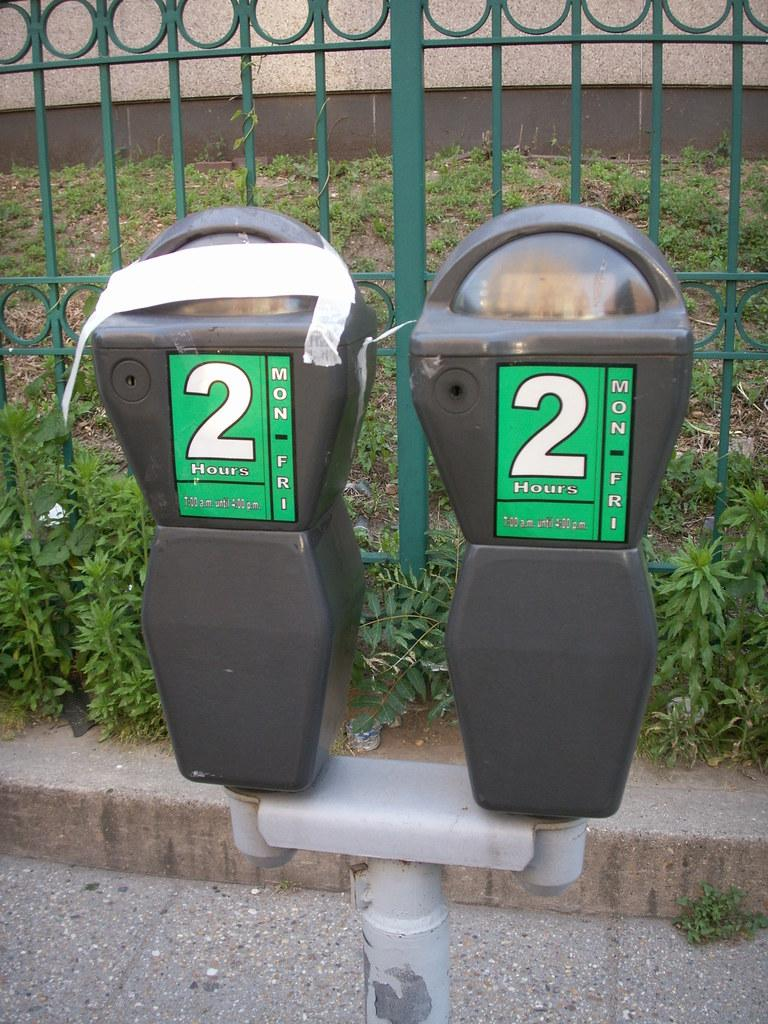<image>
Write a terse but informative summary of the picture. Two parking meters with two hour stickers on them. 